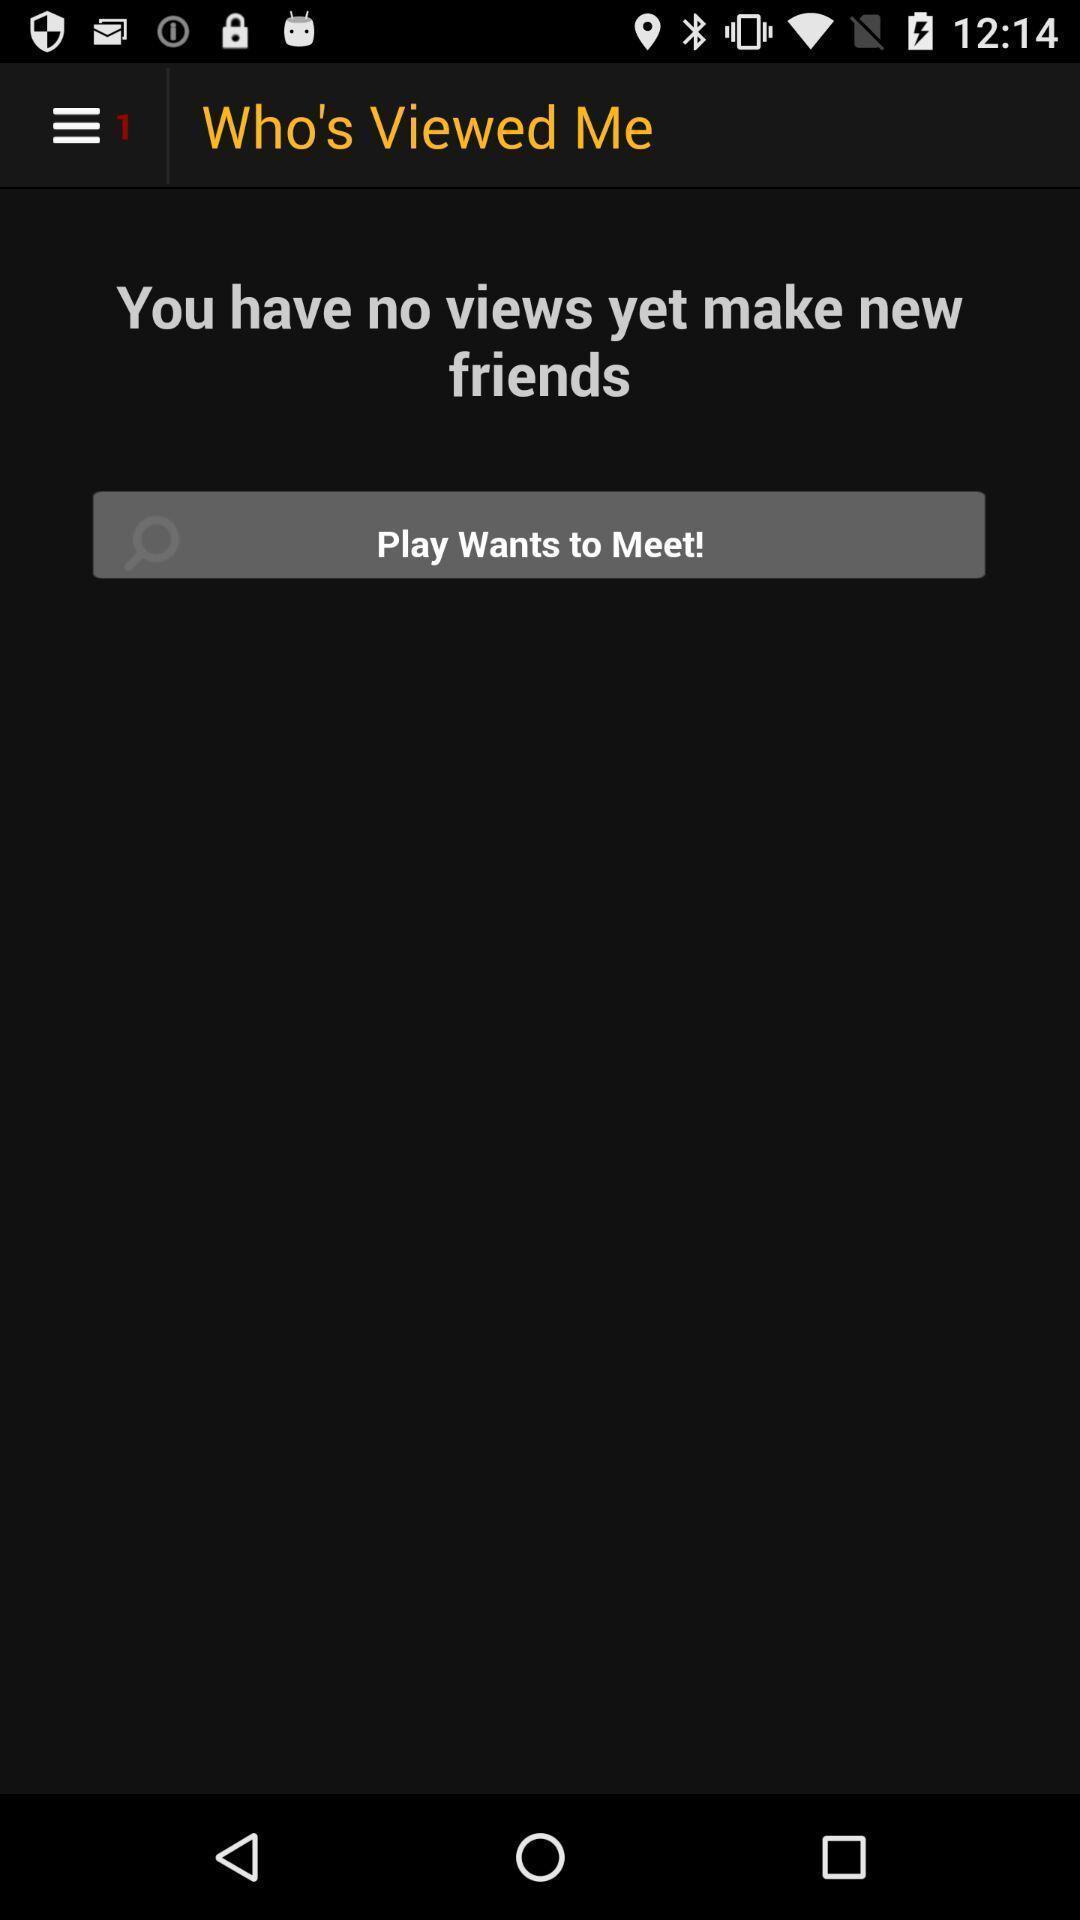Give me a narrative description of this picture. Screen page of a social application. 